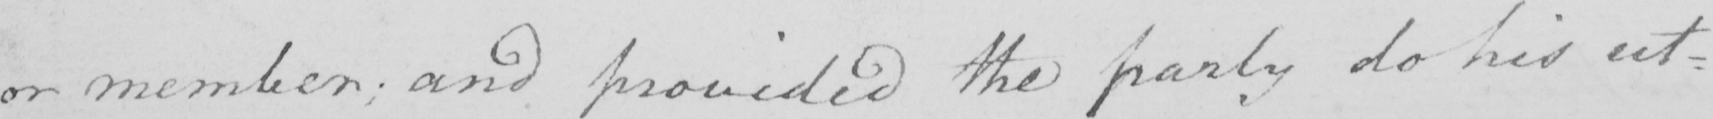Transcribe the text shown in this historical manuscript line. or member ; and provided the party do his ut= 